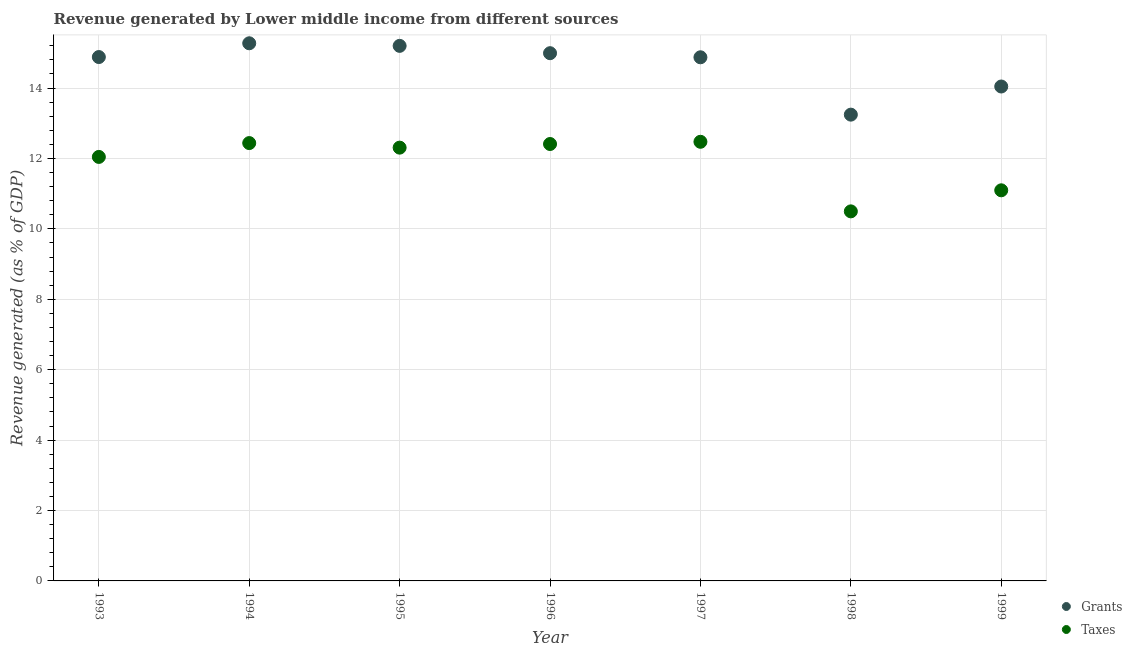How many different coloured dotlines are there?
Your response must be concise. 2. Is the number of dotlines equal to the number of legend labels?
Your answer should be very brief. Yes. What is the revenue generated by taxes in 1993?
Keep it short and to the point. 12.04. Across all years, what is the maximum revenue generated by taxes?
Your response must be concise. 12.47. Across all years, what is the minimum revenue generated by taxes?
Your response must be concise. 10.5. In which year was the revenue generated by taxes minimum?
Offer a terse response. 1998. What is the total revenue generated by grants in the graph?
Your answer should be compact. 102.51. What is the difference between the revenue generated by taxes in 1994 and that in 1998?
Give a very brief answer. 1.94. What is the difference between the revenue generated by grants in 1999 and the revenue generated by taxes in 1995?
Offer a terse response. 1.74. What is the average revenue generated by taxes per year?
Provide a succinct answer. 11.9. In the year 1995, what is the difference between the revenue generated by taxes and revenue generated by grants?
Ensure brevity in your answer.  -2.89. What is the ratio of the revenue generated by taxes in 1994 to that in 1999?
Make the answer very short. 1.12. Is the revenue generated by taxes in 1995 less than that in 1997?
Provide a succinct answer. Yes. Is the difference between the revenue generated by grants in 1994 and 1996 greater than the difference between the revenue generated by taxes in 1994 and 1996?
Your response must be concise. Yes. What is the difference between the highest and the second highest revenue generated by grants?
Offer a terse response. 0.07. What is the difference between the highest and the lowest revenue generated by taxes?
Offer a terse response. 1.98. Does the revenue generated by grants monotonically increase over the years?
Your response must be concise. No. Is the revenue generated by grants strictly greater than the revenue generated by taxes over the years?
Provide a short and direct response. Yes. Is the revenue generated by taxes strictly less than the revenue generated by grants over the years?
Give a very brief answer. Yes. How many dotlines are there?
Keep it short and to the point. 2. How many years are there in the graph?
Your answer should be very brief. 7. What is the difference between two consecutive major ticks on the Y-axis?
Make the answer very short. 2. Are the values on the major ticks of Y-axis written in scientific E-notation?
Your response must be concise. No. Does the graph contain any zero values?
Make the answer very short. No. Does the graph contain grids?
Ensure brevity in your answer.  Yes. Where does the legend appear in the graph?
Ensure brevity in your answer.  Bottom right. How are the legend labels stacked?
Your response must be concise. Vertical. What is the title of the graph?
Ensure brevity in your answer.  Revenue generated by Lower middle income from different sources. Does "IMF concessional" appear as one of the legend labels in the graph?
Provide a short and direct response. No. What is the label or title of the Y-axis?
Give a very brief answer. Revenue generated (as % of GDP). What is the Revenue generated (as % of GDP) of Grants in 1993?
Offer a very short reply. 14.88. What is the Revenue generated (as % of GDP) of Taxes in 1993?
Your answer should be compact. 12.04. What is the Revenue generated (as % of GDP) of Grants in 1994?
Ensure brevity in your answer.  15.27. What is the Revenue generated (as % of GDP) in Taxes in 1994?
Keep it short and to the point. 12.44. What is the Revenue generated (as % of GDP) in Grants in 1995?
Give a very brief answer. 15.2. What is the Revenue generated (as % of GDP) in Taxes in 1995?
Provide a succinct answer. 12.31. What is the Revenue generated (as % of GDP) in Grants in 1996?
Offer a terse response. 14.99. What is the Revenue generated (as % of GDP) in Taxes in 1996?
Your response must be concise. 12.41. What is the Revenue generated (as % of GDP) in Grants in 1997?
Your answer should be compact. 14.87. What is the Revenue generated (as % of GDP) in Taxes in 1997?
Provide a short and direct response. 12.47. What is the Revenue generated (as % of GDP) of Grants in 1998?
Your answer should be compact. 13.24. What is the Revenue generated (as % of GDP) of Taxes in 1998?
Your answer should be compact. 10.5. What is the Revenue generated (as % of GDP) of Grants in 1999?
Offer a very short reply. 14.04. What is the Revenue generated (as % of GDP) in Taxes in 1999?
Keep it short and to the point. 11.1. Across all years, what is the maximum Revenue generated (as % of GDP) of Grants?
Provide a short and direct response. 15.27. Across all years, what is the maximum Revenue generated (as % of GDP) in Taxes?
Offer a terse response. 12.47. Across all years, what is the minimum Revenue generated (as % of GDP) of Grants?
Offer a terse response. 13.24. Across all years, what is the minimum Revenue generated (as % of GDP) of Taxes?
Your answer should be very brief. 10.5. What is the total Revenue generated (as % of GDP) of Grants in the graph?
Ensure brevity in your answer.  102.51. What is the total Revenue generated (as % of GDP) in Taxes in the graph?
Offer a terse response. 83.27. What is the difference between the Revenue generated (as % of GDP) in Grants in 1993 and that in 1994?
Provide a short and direct response. -0.39. What is the difference between the Revenue generated (as % of GDP) of Taxes in 1993 and that in 1994?
Provide a short and direct response. -0.39. What is the difference between the Revenue generated (as % of GDP) of Grants in 1993 and that in 1995?
Keep it short and to the point. -0.32. What is the difference between the Revenue generated (as % of GDP) in Taxes in 1993 and that in 1995?
Your answer should be compact. -0.26. What is the difference between the Revenue generated (as % of GDP) of Grants in 1993 and that in 1996?
Your response must be concise. -0.11. What is the difference between the Revenue generated (as % of GDP) in Taxes in 1993 and that in 1996?
Make the answer very short. -0.37. What is the difference between the Revenue generated (as % of GDP) of Grants in 1993 and that in 1997?
Make the answer very short. 0.01. What is the difference between the Revenue generated (as % of GDP) of Taxes in 1993 and that in 1997?
Provide a short and direct response. -0.43. What is the difference between the Revenue generated (as % of GDP) of Grants in 1993 and that in 1998?
Offer a very short reply. 1.64. What is the difference between the Revenue generated (as % of GDP) in Taxes in 1993 and that in 1998?
Your response must be concise. 1.55. What is the difference between the Revenue generated (as % of GDP) in Grants in 1993 and that in 1999?
Offer a very short reply. 0.84. What is the difference between the Revenue generated (as % of GDP) in Taxes in 1993 and that in 1999?
Provide a succinct answer. 0.95. What is the difference between the Revenue generated (as % of GDP) in Grants in 1994 and that in 1995?
Your response must be concise. 0.07. What is the difference between the Revenue generated (as % of GDP) in Taxes in 1994 and that in 1995?
Give a very brief answer. 0.13. What is the difference between the Revenue generated (as % of GDP) in Grants in 1994 and that in 1996?
Offer a terse response. 0.28. What is the difference between the Revenue generated (as % of GDP) of Taxes in 1994 and that in 1996?
Keep it short and to the point. 0.03. What is the difference between the Revenue generated (as % of GDP) of Grants in 1994 and that in 1997?
Offer a terse response. 0.4. What is the difference between the Revenue generated (as % of GDP) of Taxes in 1994 and that in 1997?
Make the answer very short. -0.04. What is the difference between the Revenue generated (as % of GDP) of Grants in 1994 and that in 1998?
Keep it short and to the point. 2.03. What is the difference between the Revenue generated (as % of GDP) of Taxes in 1994 and that in 1998?
Provide a short and direct response. 1.94. What is the difference between the Revenue generated (as % of GDP) in Grants in 1994 and that in 1999?
Provide a succinct answer. 1.23. What is the difference between the Revenue generated (as % of GDP) of Taxes in 1994 and that in 1999?
Keep it short and to the point. 1.34. What is the difference between the Revenue generated (as % of GDP) of Grants in 1995 and that in 1996?
Provide a short and direct response. 0.21. What is the difference between the Revenue generated (as % of GDP) of Taxes in 1995 and that in 1996?
Provide a succinct answer. -0.1. What is the difference between the Revenue generated (as % of GDP) of Grants in 1995 and that in 1997?
Ensure brevity in your answer.  0.32. What is the difference between the Revenue generated (as % of GDP) of Taxes in 1995 and that in 1997?
Provide a succinct answer. -0.17. What is the difference between the Revenue generated (as % of GDP) of Grants in 1995 and that in 1998?
Keep it short and to the point. 1.95. What is the difference between the Revenue generated (as % of GDP) of Taxes in 1995 and that in 1998?
Your answer should be very brief. 1.81. What is the difference between the Revenue generated (as % of GDP) of Grants in 1995 and that in 1999?
Offer a very short reply. 1.15. What is the difference between the Revenue generated (as % of GDP) of Taxes in 1995 and that in 1999?
Provide a short and direct response. 1.21. What is the difference between the Revenue generated (as % of GDP) in Grants in 1996 and that in 1997?
Give a very brief answer. 0.12. What is the difference between the Revenue generated (as % of GDP) in Taxes in 1996 and that in 1997?
Make the answer very short. -0.06. What is the difference between the Revenue generated (as % of GDP) of Grants in 1996 and that in 1998?
Your response must be concise. 1.75. What is the difference between the Revenue generated (as % of GDP) of Taxes in 1996 and that in 1998?
Ensure brevity in your answer.  1.91. What is the difference between the Revenue generated (as % of GDP) of Grants in 1996 and that in 1999?
Your response must be concise. 0.95. What is the difference between the Revenue generated (as % of GDP) in Taxes in 1996 and that in 1999?
Make the answer very short. 1.32. What is the difference between the Revenue generated (as % of GDP) of Grants in 1997 and that in 1998?
Your answer should be very brief. 1.63. What is the difference between the Revenue generated (as % of GDP) of Taxes in 1997 and that in 1998?
Give a very brief answer. 1.98. What is the difference between the Revenue generated (as % of GDP) of Grants in 1997 and that in 1999?
Your answer should be compact. 0.83. What is the difference between the Revenue generated (as % of GDP) in Taxes in 1997 and that in 1999?
Provide a succinct answer. 1.38. What is the difference between the Revenue generated (as % of GDP) in Grants in 1998 and that in 1999?
Provide a succinct answer. -0.8. What is the difference between the Revenue generated (as % of GDP) of Taxes in 1998 and that in 1999?
Keep it short and to the point. -0.6. What is the difference between the Revenue generated (as % of GDP) of Grants in 1993 and the Revenue generated (as % of GDP) of Taxes in 1994?
Make the answer very short. 2.44. What is the difference between the Revenue generated (as % of GDP) in Grants in 1993 and the Revenue generated (as % of GDP) in Taxes in 1995?
Offer a terse response. 2.57. What is the difference between the Revenue generated (as % of GDP) in Grants in 1993 and the Revenue generated (as % of GDP) in Taxes in 1996?
Make the answer very short. 2.47. What is the difference between the Revenue generated (as % of GDP) in Grants in 1993 and the Revenue generated (as % of GDP) in Taxes in 1997?
Provide a short and direct response. 2.41. What is the difference between the Revenue generated (as % of GDP) in Grants in 1993 and the Revenue generated (as % of GDP) in Taxes in 1998?
Provide a succinct answer. 4.38. What is the difference between the Revenue generated (as % of GDP) of Grants in 1993 and the Revenue generated (as % of GDP) of Taxes in 1999?
Ensure brevity in your answer.  3.79. What is the difference between the Revenue generated (as % of GDP) in Grants in 1994 and the Revenue generated (as % of GDP) in Taxes in 1995?
Offer a terse response. 2.96. What is the difference between the Revenue generated (as % of GDP) of Grants in 1994 and the Revenue generated (as % of GDP) of Taxes in 1996?
Offer a terse response. 2.86. What is the difference between the Revenue generated (as % of GDP) of Grants in 1994 and the Revenue generated (as % of GDP) of Taxes in 1997?
Your response must be concise. 2.8. What is the difference between the Revenue generated (as % of GDP) in Grants in 1994 and the Revenue generated (as % of GDP) in Taxes in 1998?
Make the answer very short. 4.77. What is the difference between the Revenue generated (as % of GDP) of Grants in 1994 and the Revenue generated (as % of GDP) of Taxes in 1999?
Keep it short and to the point. 4.18. What is the difference between the Revenue generated (as % of GDP) in Grants in 1995 and the Revenue generated (as % of GDP) in Taxes in 1996?
Offer a very short reply. 2.79. What is the difference between the Revenue generated (as % of GDP) in Grants in 1995 and the Revenue generated (as % of GDP) in Taxes in 1997?
Your answer should be very brief. 2.72. What is the difference between the Revenue generated (as % of GDP) of Grants in 1995 and the Revenue generated (as % of GDP) of Taxes in 1998?
Offer a very short reply. 4.7. What is the difference between the Revenue generated (as % of GDP) in Grants in 1995 and the Revenue generated (as % of GDP) in Taxes in 1999?
Your response must be concise. 4.1. What is the difference between the Revenue generated (as % of GDP) in Grants in 1996 and the Revenue generated (as % of GDP) in Taxes in 1997?
Ensure brevity in your answer.  2.52. What is the difference between the Revenue generated (as % of GDP) in Grants in 1996 and the Revenue generated (as % of GDP) in Taxes in 1998?
Your response must be concise. 4.49. What is the difference between the Revenue generated (as % of GDP) in Grants in 1996 and the Revenue generated (as % of GDP) in Taxes in 1999?
Give a very brief answer. 3.9. What is the difference between the Revenue generated (as % of GDP) in Grants in 1997 and the Revenue generated (as % of GDP) in Taxes in 1998?
Your answer should be compact. 4.38. What is the difference between the Revenue generated (as % of GDP) of Grants in 1997 and the Revenue generated (as % of GDP) of Taxes in 1999?
Give a very brief answer. 3.78. What is the difference between the Revenue generated (as % of GDP) in Grants in 1998 and the Revenue generated (as % of GDP) in Taxes in 1999?
Ensure brevity in your answer.  2.15. What is the average Revenue generated (as % of GDP) in Grants per year?
Provide a succinct answer. 14.64. What is the average Revenue generated (as % of GDP) of Taxes per year?
Provide a succinct answer. 11.9. In the year 1993, what is the difference between the Revenue generated (as % of GDP) in Grants and Revenue generated (as % of GDP) in Taxes?
Provide a succinct answer. 2.84. In the year 1994, what is the difference between the Revenue generated (as % of GDP) of Grants and Revenue generated (as % of GDP) of Taxes?
Provide a succinct answer. 2.83. In the year 1995, what is the difference between the Revenue generated (as % of GDP) in Grants and Revenue generated (as % of GDP) in Taxes?
Provide a short and direct response. 2.89. In the year 1996, what is the difference between the Revenue generated (as % of GDP) of Grants and Revenue generated (as % of GDP) of Taxes?
Offer a very short reply. 2.58. In the year 1997, what is the difference between the Revenue generated (as % of GDP) in Grants and Revenue generated (as % of GDP) in Taxes?
Your response must be concise. 2.4. In the year 1998, what is the difference between the Revenue generated (as % of GDP) of Grants and Revenue generated (as % of GDP) of Taxes?
Offer a very short reply. 2.75. In the year 1999, what is the difference between the Revenue generated (as % of GDP) of Grants and Revenue generated (as % of GDP) of Taxes?
Your answer should be compact. 2.95. What is the ratio of the Revenue generated (as % of GDP) in Grants in 1993 to that in 1994?
Offer a terse response. 0.97. What is the ratio of the Revenue generated (as % of GDP) in Taxes in 1993 to that in 1994?
Offer a very short reply. 0.97. What is the ratio of the Revenue generated (as % of GDP) in Grants in 1993 to that in 1995?
Give a very brief answer. 0.98. What is the ratio of the Revenue generated (as % of GDP) in Taxes in 1993 to that in 1995?
Make the answer very short. 0.98. What is the ratio of the Revenue generated (as % of GDP) in Taxes in 1993 to that in 1996?
Offer a very short reply. 0.97. What is the ratio of the Revenue generated (as % of GDP) of Grants in 1993 to that in 1997?
Ensure brevity in your answer.  1. What is the ratio of the Revenue generated (as % of GDP) of Taxes in 1993 to that in 1997?
Offer a very short reply. 0.97. What is the ratio of the Revenue generated (as % of GDP) of Grants in 1993 to that in 1998?
Give a very brief answer. 1.12. What is the ratio of the Revenue generated (as % of GDP) in Taxes in 1993 to that in 1998?
Make the answer very short. 1.15. What is the ratio of the Revenue generated (as % of GDP) of Grants in 1993 to that in 1999?
Your answer should be compact. 1.06. What is the ratio of the Revenue generated (as % of GDP) in Taxes in 1993 to that in 1999?
Your answer should be compact. 1.09. What is the ratio of the Revenue generated (as % of GDP) in Taxes in 1994 to that in 1995?
Make the answer very short. 1.01. What is the ratio of the Revenue generated (as % of GDP) in Grants in 1994 to that in 1996?
Your answer should be very brief. 1.02. What is the ratio of the Revenue generated (as % of GDP) of Taxes in 1994 to that in 1996?
Keep it short and to the point. 1. What is the ratio of the Revenue generated (as % of GDP) of Grants in 1994 to that in 1997?
Provide a succinct answer. 1.03. What is the ratio of the Revenue generated (as % of GDP) of Grants in 1994 to that in 1998?
Provide a succinct answer. 1.15. What is the ratio of the Revenue generated (as % of GDP) in Taxes in 1994 to that in 1998?
Make the answer very short. 1.18. What is the ratio of the Revenue generated (as % of GDP) of Grants in 1994 to that in 1999?
Give a very brief answer. 1.09. What is the ratio of the Revenue generated (as % of GDP) in Taxes in 1994 to that in 1999?
Your answer should be compact. 1.12. What is the ratio of the Revenue generated (as % of GDP) of Grants in 1995 to that in 1996?
Provide a succinct answer. 1.01. What is the ratio of the Revenue generated (as % of GDP) of Taxes in 1995 to that in 1996?
Offer a very short reply. 0.99. What is the ratio of the Revenue generated (as % of GDP) of Grants in 1995 to that in 1997?
Provide a short and direct response. 1.02. What is the ratio of the Revenue generated (as % of GDP) in Taxes in 1995 to that in 1997?
Provide a short and direct response. 0.99. What is the ratio of the Revenue generated (as % of GDP) of Grants in 1995 to that in 1998?
Offer a terse response. 1.15. What is the ratio of the Revenue generated (as % of GDP) in Taxes in 1995 to that in 1998?
Your answer should be compact. 1.17. What is the ratio of the Revenue generated (as % of GDP) in Grants in 1995 to that in 1999?
Offer a terse response. 1.08. What is the ratio of the Revenue generated (as % of GDP) in Taxes in 1995 to that in 1999?
Keep it short and to the point. 1.11. What is the ratio of the Revenue generated (as % of GDP) of Grants in 1996 to that in 1997?
Provide a succinct answer. 1.01. What is the ratio of the Revenue generated (as % of GDP) in Taxes in 1996 to that in 1997?
Your answer should be very brief. 0.99. What is the ratio of the Revenue generated (as % of GDP) of Grants in 1996 to that in 1998?
Make the answer very short. 1.13. What is the ratio of the Revenue generated (as % of GDP) in Taxes in 1996 to that in 1998?
Give a very brief answer. 1.18. What is the ratio of the Revenue generated (as % of GDP) of Grants in 1996 to that in 1999?
Your response must be concise. 1.07. What is the ratio of the Revenue generated (as % of GDP) in Taxes in 1996 to that in 1999?
Your response must be concise. 1.12. What is the ratio of the Revenue generated (as % of GDP) of Grants in 1997 to that in 1998?
Your answer should be very brief. 1.12. What is the ratio of the Revenue generated (as % of GDP) of Taxes in 1997 to that in 1998?
Your answer should be very brief. 1.19. What is the ratio of the Revenue generated (as % of GDP) of Grants in 1997 to that in 1999?
Provide a short and direct response. 1.06. What is the ratio of the Revenue generated (as % of GDP) of Taxes in 1997 to that in 1999?
Offer a terse response. 1.12. What is the ratio of the Revenue generated (as % of GDP) of Grants in 1998 to that in 1999?
Your answer should be compact. 0.94. What is the ratio of the Revenue generated (as % of GDP) in Taxes in 1998 to that in 1999?
Give a very brief answer. 0.95. What is the difference between the highest and the second highest Revenue generated (as % of GDP) of Grants?
Your answer should be very brief. 0.07. What is the difference between the highest and the second highest Revenue generated (as % of GDP) of Taxes?
Give a very brief answer. 0.04. What is the difference between the highest and the lowest Revenue generated (as % of GDP) in Grants?
Make the answer very short. 2.03. What is the difference between the highest and the lowest Revenue generated (as % of GDP) in Taxes?
Your answer should be very brief. 1.98. 